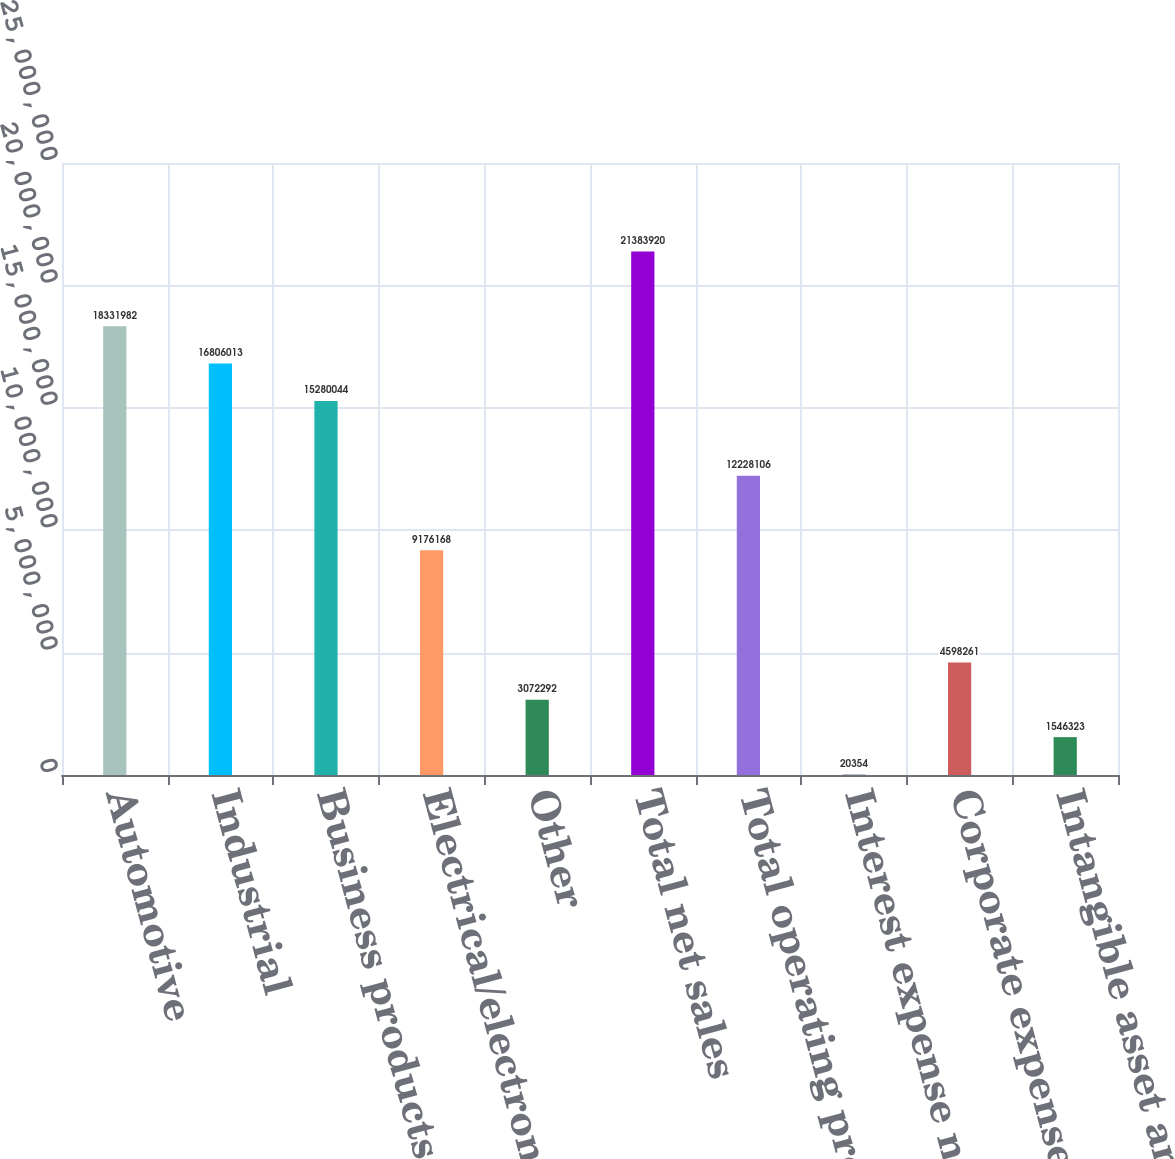<chart> <loc_0><loc_0><loc_500><loc_500><bar_chart><fcel>Automotive<fcel>Industrial<fcel>Business products<fcel>Electrical/electronic<fcel>Other<fcel>Total net sales<fcel>Total operating profit<fcel>Interest expense net<fcel>Corporate expense<fcel>Intangible asset amortization<nl><fcel>1.8332e+07<fcel>1.6806e+07<fcel>1.528e+07<fcel>9.17617e+06<fcel>3.07229e+06<fcel>2.13839e+07<fcel>1.22281e+07<fcel>20354<fcel>4.59826e+06<fcel>1.54632e+06<nl></chart> 